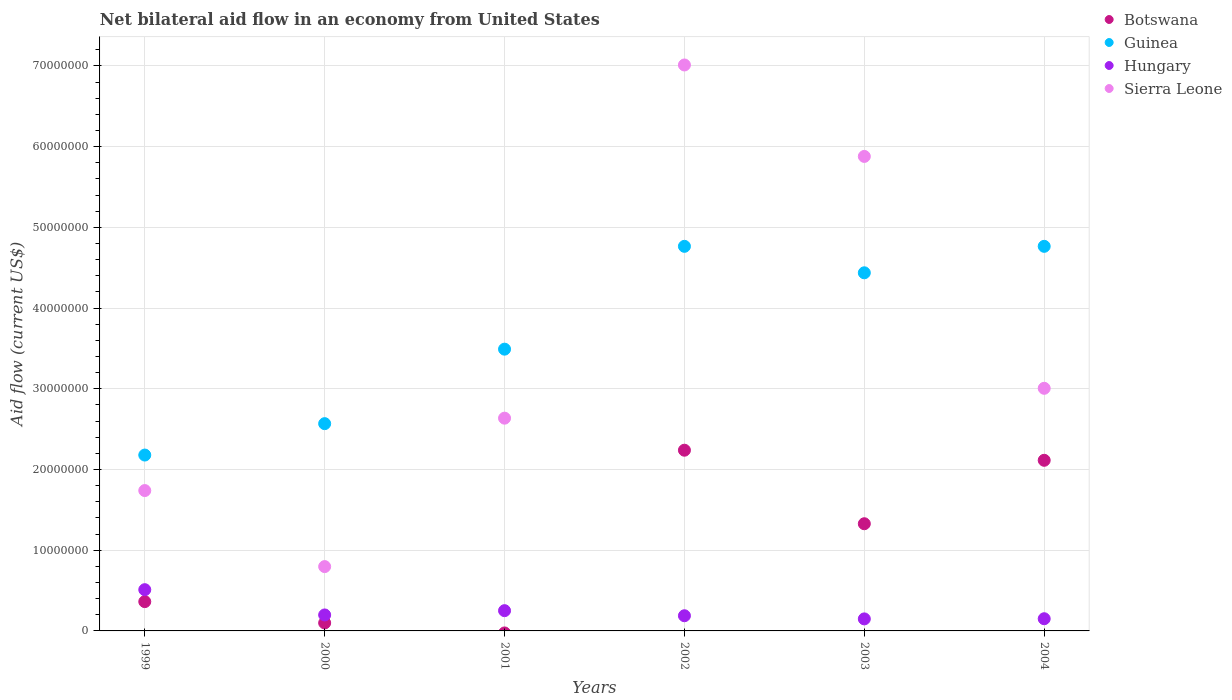How many different coloured dotlines are there?
Keep it short and to the point. 4. Is the number of dotlines equal to the number of legend labels?
Offer a very short reply. No. What is the net bilateral aid flow in Hungary in 2002?
Your answer should be very brief. 1.88e+06. Across all years, what is the maximum net bilateral aid flow in Botswana?
Offer a terse response. 2.24e+07. Across all years, what is the minimum net bilateral aid flow in Guinea?
Your answer should be compact. 2.18e+07. In which year was the net bilateral aid flow in Botswana maximum?
Provide a succinct answer. 2002. What is the total net bilateral aid flow in Hungary in the graph?
Offer a very short reply. 1.45e+07. What is the difference between the net bilateral aid flow in Botswana in 1999 and that in 2002?
Offer a very short reply. -1.88e+07. What is the difference between the net bilateral aid flow in Hungary in 2002 and the net bilateral aid flow in Guinea in 1999?
Your answer should be compact. -1.99e+07. What is the average net bilateral aid flow in Hungary per year?
Give a very brief answer. 2.41e+06. In the year 1999, what is the difference between the net bilateral aid flow in Guinea and net bilateral aid flow in Botswana?
Give a very brief answer. 1.82e+07. What is the ratio of the net bilateral aid flow in Hungary in 2000 to that in 2004?
Your response must be concise. 1.31. Is the difference between the net bilateral aid flow in Guinea in 1999 and 2002 greater than the difference between the net bilateral aid flow in Botswana in 1999 and 2002?
Make the answer very short. No. What is the difference between the highest and the second highest net bilateral aid flow in Guinea?
Give a very brief answer. 0. What is the difference between the highest and the lowest net bilateral aid flow in Guinea?
Give a very brief answer. 2.59e+07. In how many years, is the net bilateral aid flow in Hungary greater than the average net bilateral aid flow in Hungary taken over all years?
Offer a terse response. 2. How many dotlines are there?
Keep it short and to the point. 4. What is the difference between two consecutive major ticks on the Y-axis?
Provide a succinct answer. 1.00e+07. Are the values on the major ticks of Y-axis written in scientific E-notation?
Ensure brevity in your answer.  No. Does the graph contain grids?
Make the answer very short. Yes. Where does the legend appear in the graph?
Offer a very short reply. Top right. How many legend labels are there?
Provide a succinct answer. 4. How are the legend labels stacked?
Offer a terse response. Vertical. What is the title of the graph?
Ensure brevity in your answer.  Net bilateral aid flow in an economy from United States. What is the label or title of the X-axis?
Provide a short and direct response. Years. What is the label or title of the Y-axis?
Offer a very short reply. Aid flow (current US$). What is the Aid flow (current US$) of Botswana in 1999?
Provide a succinct answer. 3.63e+06. What is the Aid flow (current US$) of Guinea in 1999?
Your answer should be very brief. 2.18e+07. What is the Aid flow (current US$) in Hungary in 1999?
Make the answer very short. 5.11e+06. What is the Aid flow (current US$) in Sierra Leone in 1999?
Provide a short and direct response. 1.74e+07. What is the Aid flow (current US$) in Botswana in 2000?
Your response must be concise. 9.90e+05. What is the Aid flow (current US$) of Guinea in 2000?
Give a very brief answer. 2.57e+07. What is the Aid flow (current US$) of Hungary in 2000?
Your response must be concise. 1.98e+06. What is the Aid flow (current US$) of Sierra Leone in 2000?
Offer a terse response. 7.97e+06. What is the Aid flow (current US$) in Botswana in 2001?
Keep it short and to the point. 0. What is the Aid flow (current US$) in Guinea in 2001?
Provide a succinct answer. 3.49e+07. What is the Aid flow (current US$) in Hungary in 2001?
Offer a very short reply. 2.51e+06. What is the Aid flow (current US$) in Sierra Leone in 2001?
Provide a short and direct response. 2.64e+07. What is the Aid flow (current US$) in Botswana in 2002?
Provide a short and direct response. 2.24e+07. What is the Aid flow (current US$) in Guinea in 2002?
Your answer should be compact. 4.76e+07. What is the Aid flow (current US$) of Hungary in 2002?
Your response must be concise. 1.88e+06. What is the Aid flow (current US$) of Sierra Leone in 2002?
Give a very brief answer. 7.01e+07. What is the Aid flow (current US$) of Botswana in 2003?
Your response must be concise. 1.33e+07. What is the Aid flow (current US$) of Guinea in 2003?
Ensure brevity in your answer.  4.44e+07. What is the Aid flow (current US$) of Hungary in 2003?
Give a very brief answer. 1.49e+06. What is the Aid flow (current US$) of Sierra Leone in 2003?
Provide a short and direct response. 5.88e+07. What is the Aid flow (current US$) of Botswana in 2004?
Provide a short and direct response. 2.11e+07. What is the Aid flow (current US$) of Guinea in 2004?
Provide a succinct answer. 4.76e+07. What is the Aid flow (current US$) in Hungary in 2004?
Offer a terse response. 1.51e+06. What is the Aid flow (current US$) in Sierra Leone in 2004?
Your answer should be compact. 3.01e+07. Across all years, what is the maximum Aid flow (current US$) in Botswana?
Provide a succinct answer. 2.24e+07. Across all years, what is the maximum Aid flow (current US$) of Guinea?
Your response must be concise. 4.76e+07. Across all years, what is the maximum Aid flow (current US$) in Hungary?
Keep it short and to the point. 5.11e+06. Across all years, what is the maximum Aid flow (current US$) of Sierra Leone?
Give a very brief answer. 7.01e+07. Across all years, what is the minimum Aid flow (current US$) of Botswana?
Provide a short and direct response. 0. Across all years, what is the minimum Aid flow (current US$) in Guinea?
Make the answer very short. 2.18e+07. Across all years, what is the minimum Aid flow (current US$) of Hungary?
Keep it short and to the point. 1.49e+06. Across all years, what is the minimum Aid flow (current US$) in Sierra Leone?
Your answer should be very brief. 7.97e+06. What is the total Aid flow (current US$) in Botswana in the graph?
Offer a terse response. 6.14e+07. What is the total Aid flow (current US$) of Guinea in the graph?
Make the answer very short. 2.22e+08. What is the total Aid flow (current US$) in Hungary in the graph?
Ensure brevity in your answer.  1.45e+07. What is the total Aid flow (current US$) in Sierra Leone in the graph?
Offer a very short reply. 2.11e+08. What is the difference between the Aid flow (current US$) in Botswana in 1999 and that in 2000?
Provide a short and direct response. 2.64e+06. What is the difference between the Aid flow (current US$) in Guinea in 1999 and that in 2000?
Your answer should be very brief. -3.89e+06. What is the difference between the Aid flow (current US$) in Hungary in 1999 and that in 2000?
Your answer should be compact. 3.13e+06. What is the difference between the Aid flow (current US$) of Sierra Leone in 1999 and that in 2000?
Give a very brief answer. 9.42e+06. What is the difference between the Aid flow (current US$) of Guinea in 1999 and that in 2001?
Your answer should be compact. -1.31e+07. What is the difference between the Aid flow (current US$) of Hungary in 1999 and that in 2001?
Ensure brevity in your answer.  2.60e+06. What is the difference between the Aid flow (current US$) in Sierra Leone in 1999 and that in 2001?
Your response must be concise. -8.97e+06. What is the difference between the Aid flow (current US$) of Botswana in 1999 and that in 2002?
Make the answer very short. -1.88e+07. What is the difference between the Aid flow (current US$) of Guinea in 1999 and that in 2002?
Keep it short and to the point. -2.59e+07. What is the difference between the Aid flow (current US$) in Hungary in 1999 and that in 2002?
Your answer should be compact. 3.23e+06. What is the difference between the Aid flow (current US$) in Sierra Leone in 1999 and that in 2002?
Provide a short and direct response. -5.27e+07. What is the difference between the Aid flow (current US$) of Botswana in 1999 and that in 2003?
Provide a succinct answer. -9.65e+06. What is the difference between the Aid flow (current US$) of Guinea in 1999 and that in 2003?
Make the answer very short. -2.26e+07. What is the difference between the Aid flow (current US$) of Hungary in 1999 and that in 2003?
Your answer should be compact. 3.62e+06. What is the difference between the Aid flow (current US$) of Sierra Leone in 1999 and that in 2003?
Your answer should be compact. -4.14e+07. What is the difference between the Aid flow (current US$) of Botswana in 1999 and that in 2004?
Your answer should be compact. -1.75e+07. What is the difference between the Aid flow (current US$) in Guinea in 1999 and that in 2004?
Offer a very short reply. -2.59e+07. What is the difference between the Aid flow (current US$) of Hungary in 1999 and that in 2004?
Give a very brief answer. 3.60e+06. What is the difference between the Aid flow (current US$) in Sierra Leone in 1999 and that in 2004?
Your response must be concise. -1.27e+07. What is the difference between the Aid flow (current US$) in Guinea in 2000 and that in 2001?
Provide a succinct answer. -9.23e+06. What is the difference between the Aid flow (current US$) in Hungary in 2000 and that in 2001?
Your answer should be compact. -5.30e+05. What is the difference between the Aid flow (current US$) of Sierra Leone in 2000 and that in 2001?
Ensure brevity in your answer.  -1.84e+07. What is the difference between the Aid flow (current US$) of Botswana in 2000 and that in 2002?
Your answer should be compact. -2.14e+07. What is the difference between the Aid flow (current US$) of Guinea in 2000 and that in 2002?
Offer a very short reply. -2.20e+07. What is the difference between the Aid flow (current US$) in Hungary in 2000 and that in 2002?
Give a very brief answer. 1.00e+05. What is the difference between the Aid flow (current US$) of Sierra Leone in 2000 and that in 2002?
Your answer should be very brief. -6.22e+07. What is the difference between the Aid flow (current US$) of Botswana in 2000 and that in 2003?
Give a very brief answer. -1.23e+07. What is the difference between the Aid flow (current US$) in Guinea in 2000 and that in 2003?
Keep it short and to the point. -1.87e+07. What is the difference between the Aid flow (current US$) in Hungary in 2000 and that in 2003?
Offer a very short reply. 4.90e+05. What is the difference between the Aid flow (current US$) in Sierra Leone in 2000 and that in 2003?
Provide a succinct answer. -5.08e+07. What is the difference between the Aid flow (current US$) in Botswana in 2000 and that in 2004?
Keep it short and to the point. -2.02e+07. What is the difference between the Aid flow (current US$) in Guinea in 2000 and that in 2004?
Keep it short and to the point. -2.20e+07. What is the difference between the Aid flow (current US$) in Sierra Leone in 2000 and that in 2004?
Give a very brief answer. -2.21e+07. What is the difference between the Aid flow (current US$) of Guinea in 2001 and that in 2002?
Keep it short and to the point. -1.27e+07. What is the difference between the Aid flow (current US$) of Hungary in 2001 and that in 2002?
Make the answer very short. 6.30e+05. What is the difference between the Aid flow (current US$) in Sierra Leone in 2001 and that in 2002?
Offer a very short reply. -4.38e+07. What is the difference between the Aid flow (current US$) of Guinea in 2001 and that in 2003?
Provide a short and direct response. -9.46e+06. What is the difference between the Aid flow (current US$) in Hungary in 2001 and that in 2003?
Keep it short and to the point. 1.02e+06. What is the difference between the Aid flow (current US$) of Sierra Leone in 2001 and that in 2003?
Offer a very short reply. -3.24e+07. What is the difference between the Aid flow (current US$) in Guinea in 2001 and that in 2004?
Offer a very short reply. -1.27e+07. What is the difference between the Aid flow (current US$) of Sierra Leone in 2001 and that in 2004?
Provide a succinct answer. -3.70e+06. What is the difference between the Aid flow (current US$) in Botswana in 2002 and that in 2003?
Keep it short and to the point. 9.11e+06. What is the difference between the Aid flow (current US$) in Guinea in 2002 and that in 2003?
Keep it short and to the point. 3.28e+06. What is the difference between the Aid flow (current US$) in Hungary in 2002 and that in 2003?
Your answer should be compact. 3.90e+05. What is the difference between the Aid flow (current US$) in Sierra Leone in 2002 and that in 2003?
Your answer should be compact. 1.13e+07. What is the difference between the Aid flow (current US$) in Botswana in 2002 and that in 2004?
Offer a terse response. 1.25e+06. What is the difference between the Aid flow (current US$) of Sierra Leone in 2002 and that in 2004?
Your answer should be very brief. 4.01e+07. What is the difference between the Aid flow (current US$) in Botswana in 2003 and that in 2004?
Ensure brevity in your answer.  -7.86e+06. What is the difference between the Aid flow (current US$) in Guinea in 2003 and that in 2004?
Provide a succinct answer. -3.28e+06. What is the difference between the Aid flow (current US$) in Hungary in 2003 and that in 2004?
Make the answer very short. -2.00e+04. What is the difference between the Aid flow (current US$) in Sierra Leone in 2003 and that in 2004?
Make the answer very short. 2.87e+07. What is the difference between the Aid flow (current US$) in Botswana in 1999 and the Aid flow (current US$) in Guinea in 2000?
Provide a succinct answer. -2.20e+07. What is the difference between the Aid flow (current US$) of Botswana in 1999 and the Aid flow (current US$) of Hungary in 2000?
Provide a short and direct response. 1.65e+06. What is the difference between the Aid flow (current US$) in Botswana in 1999 and the Aid flow (current US$) in Sierra Leone in 2000?
Keep it short and to the point. -4.34e+06. What is the difference between the Aid flow (current US$) in Guinea in 1999 and the Aid flow (current US$) in Hungary in 2000?
Provide a succinct answer. 1.98e+07. What is the difference between the Aid flow (current US$) in Guinea in 1999 and the Aid flow (current US$) in Sierra Leone in 2000?
Offer a very short reply. 1.38e+07. What is the difference between the Aid flow (current US$) of Hungary in 1999 and the Aid flow (current US$) of Sierra Leone in 2000?
Your response must be concise. -2.86e+06. What is the difference between the Aid flow (current US$) in Botswana in 1999 and the Aid flow (current US$) in Guinea in 2001?
Ensure brevity in your answer.  -3.13e+07. What is the difference between the Aid flow (current US$) in Botswana in 1999 and the Aid flow (current US$) in Hungary in 2001?
Provide a short and direct response. 1.12e+06. What is the difference between the Aid flow (current US$) of Botswana in 1999 and the Aid flow (current US$) of Sierra Leone in 2001?
Offer a terse response. -2.27e+07. What is the difference between the Aid flow (current US$) of Guinea in 1999 and the Aid flow (current US$) of Hungary in 2001?
Offer a terse response. 1.93e+07. What is the difference between the Aid flow (current US$) in Guinea in 1999 and the Aid flow (current US$) in Sierra Leone in 2001?
Keep it short and to the point. -4.57e+06. What is the difference between the Aid flow (current US$) of Hungary in 1999 and the Aid flow (current US$) of Sierra Leone in 2001?
Make the answer very short. -2.12e+07. What is the difference between the Aid flow (current US$) of Botswana in 1999 and the Aid flow (current US$) of Guinea in 2002?
Offer a very short reply. -4.40e+07. What is the difference between the Aid flow (current US$) of Botswana in 1999 and the Aid flow (current US$) of Hungary in 2002?
Provide a succinct answer. 1.75e+06. What is the difference between the Aid flow (current US$) of Botswana in 1999 and the Aid flow (current US$) of Sierra Leone in 2002?
Provide a short and direct response. -6.65e+07. What is the difference between the Aid flow (current US$) of Guinea in 1999 and the Aid flow (current US$) of Hungary in 2002?
Provide a short and direct response. 1.99e+07. What is the difference between the Aid flow (current US$) in Guinea in 1999 and the Aid flow (current US$) in Sierra Leone in 2002?
Provide a short and direct response. -4.83e+07. What is the difference between the Aid flow (current US$) of Hungary in 1999 and the Aid flow (current US$) of Sierra Leone in 2002?
Keep it short and to the point. -6.50e+07. What is the difference between the Aid flow (current US$) of Botswana in 1999 and the Aid flow (current US$) of Guinea in 2003?
Your answer should be very brief. -4.07e+07. What is the difference between the Aid flow (current US$) of Botswana in 1999 and the Aid flow (current US$) of Hungary in 2003?
Your answer should be very brief. 2.14e+06. What is the difference between the Aid flow (current US$) in Botswana in 1999 and the Aid flow (current US$) in Sierra Leone in 2003?
Your response must be concise. -5.52e+07. What is the difference between the Aid flow (current US$) of Guinea in 1999 and the Aid flow (current US$) of Hungary in 2003?
Make the answer very short. 2.03e+07. What is the difference between the Aid flow (current US$) of Guinea in 1999 and the Aid flow (current US$) of Sierra Leone in 2003?
Keep it short and to the point. -3.70e+07. What is the difference between the Aid flow (current US$) in Hungary in 1999 and the Aid flow (current US$) in Sierra Leone in 2003?
Offer a terse response. -5.37e+07. What is the difference between the Aid flow (current US$) in Botswana in 1999 and the Aid flow (current US$) in Guinea in 2004?
Provide a short and direct response. -4.40e+07. What is the difference between the Aid flow (current US$) in Botswana in 1999 and the Aid flow (current US$) in Hungary in 2004?
Make the answer very short. 2.12e+06. What is the difference between the Aid flow (current US$) in Botswana in 1999 and the Aid flow (current US$) in Sierra Leone in 2004?
Make the answer very short. -2.64e+07. What is the difference between the Aid flow (current US$) in Guinea in 1999 and the Aid flow (current US$) in Hungary in 2004?
Keep it short and to the point. 2.03e+07. What is the difference between the Aid flow (current US$) in Guinea in 1999 and the Aid flow (current US$) in Sierra Leone in 2004?
Your response must be concise. -8.27e+06. What is the difference between the Aid flow (current US$) of Hungary in 1999 and the Aid flow (current US$) of Sierra Leone in 2004?
Your answer should be very brief. -2.50e+07. What is the difference between the Aid flow (current US$) of Botswana in 2000 and the Aid flow (current US$) of Guinea in 2001?
Your answer should be compact. -3.39e+07. What is the difference between the Aid flow (current US$) in Botswana in 2000 and the Aid flow (current US$) in Hungary in 2001?
Ensure brevity in your answer.  -1.52e+06. What is the difference between the Aid flow (current US$) of Botswana in 2000 and the Aid flow (current US$) of Sierra Leone in 2001?
Keep it short and to the point. -2.54e+07. What is the difference between the Aid flow (current US$) of Guinea in 2000 and the Aid flow (current US$) of Hungary in 2001?
Offer a terse response. 2.32e+07. What is the difference between the Aid flow (current US$) in Guinea in 2000 and the Aid flow (current US$) in Sierra Leone in 2001?
Your answer should be compact. -6.80e+05. What is the difference between the Aid flow (current US$) of Hungary in 2000 and the Aid flow (current US$) of Sierra Leone in 2001?
Give a very brief answer. -2.44e+07. What is the difference between the Aid flow (current US$) of Botswana in 2000 and the Aid flow (current US$) of Guinea in 2002?
Offer a terse response. -4.67e+07. What is the difference between the Aid flow (current US$) in Botswana in 2000 and the Aid flow (current US$) in Hungary in 2002?
Your answer should be compact. -8.90e+05. What is the difference between the Aid flow (current US$) in Botswana in 2000 and the Aid flow (current US$) in Sierra Leone in 2002?
Provide a succinct answer. -6.91e+07. What is the difference between the Aid flow (current US$) in Guinea in 2000 and the Aid flow (current US$) in Hungary in 2002?
Offer a terse response. 2.38e+07. What is the difference between the Aid flow (current US$) in Guinea in 2000 and the Aid flow (current US$) in Sierra Leone in 2002?
Keep it short and to the point. -4.44e+07. What is the difference between the Aid flow (current US$) of Hungary in 2000 and the Aid flow (current US$) of Sierra Leone in 2002?
Keep it short and to the point. -6.81e+07. What is the difference between the Aid flow (current US$) of Botswana in 2000 and the Aid flow (current US$) of Guinea in 2003?
Your answer should be compact. -4.34e+07. What is the difference between the Aid flow (current US$) of Botswana in 2000 and the Aid flow (current US$) of Hungary in 2003?
Offer a terse response. -5.00e+05. What is the difference between the Aid flow (current US$) of Botswana in 2000 and the Aid flow (current US$) of Sierra Leone in 2003?
Ensure brevity in your answer.  -5.78e+07. What is the difference between the Aid flow (current US$) of Guinea in 2000 and the Aid flow (current US$) of Hungary in 2003?
Offer a terse response. 2.42e+07. What is the difference between the Aid flow (current US$) in Guinea in 2000 and the Aid flow (current US$) in Sierra Leone in 2003?
Give a very brief answer. -3.31e+07. What is the difference between the Aid flow (current US$) of Hungary in 2000 and the Aid flow (current US$) of Sierra Leone in 2003?
Make the answer very short. -5.68e+07. What is the difference between the Aid flow (current US$) in Botswana in 2000 and the Aid flow (current US$) in Guinea in 2004?
Your answer should be compact. -4.67e+07. What is the difference between the Aid flow (current US$) in Botswana in 2000 and the Aid flow (current US$) in Hungary in 2004?
Make the answer very short. -5.20e+05. What is the difference between the Aid flow (current US$) of Botswana in 2000 and the Aid flow (current US$) of Sierra Leone in 2004?
Ensure brevity in your answer.  -2.91e+07. What is the difference between the Aid flow (current US$) of Guinea in 2000 and the Aid flow (current US$) of Hungary in 2004?
Your response must be concise. 2.42e+07. What is the difference between the Aid flow (current US$) of Guinea in 2000 and the Aid flow (current US$) of Sierra Leone in 2004?
Your response must be concise. -4.38e+06. What is the difference between the Aid flow (current US$) in Hungary in 2000 and the Aid flow (current US$) in Sierra Leone in 2004?
Make the answer very short. -2.81e+07. What is the difference between the Aid flow (current US$) of Guinea in 2001 and the Aid flow (current US$) of Hungary in 2002?
Provide a short and direct response. 3.30e+07. What is the difference between the Aid flow (current US$) of Guinea in 2001 and the Aid flow (current US$) of Sierra Leone in 2002?
Provide a short and direct response. -3.52e+07. What is the difference between the Aid flow (current US$) in Hungary in 2001 and the Aid flow (current US$) in Sierra Leone in 2002?
Offer a very short reply. -6.76e+07. What is the difference between the Aid flow (current US$) in Guinea in 2001 and the Aid flow (current US$) in Hungary in 2003?
Offer a very short reply. 3.34e+07. What is the difference between the Aid flow (current US$) of Guinea in 2001 and the Aid flow (current US$) of Sierra Leone in 2003?
Offer a terse response. -2.39e+07. What is the difference between the Aid flow (current US$) of Hungary in 2001 and the Aid flow (current US$) of Sierra Leone in 2003?
Offer a very short reply. -5.63e+07. What is the difference between the Aid flow (current US$) in Guinea in 2001 and the Aid flow (current US$) in Hungary in 2004?
Provide a short and direct response. 3.34e+07. What is the difference between the Aid flow (current US$) of Guinea in 2001 and the Aid flow (current US$) of Sierra Leone in 2004?
Offer a very short reply. 4.85e+06. What is the difference between the Aid flow (current US$) in Hungary in 2001 and the Aid flow (current US$) in Sierra Leone in 2004?
Make the answer very short. -2.76e+07. What is the difference between the Aid flow (current US$) of Botswana in 2002 and the Aid flow (current US$) of Guinea in 2003?
Give a very brief answer. -2.20e+07. What is the difference between the Aid flow (current US$) in Botswana in 2002 and the Aid flow (current US$) in Hungary in 2003?
Provide a succinct answer. 2.09e+07. What is the difference between the Aid flow (current US$) of Botswana in 2002 and the Aid flow (current US$) of Sierra Leone in 2003?
Offer a very short reply. -3.64e+07. What is the difference between the Aid flow (current US$) of Guinea in 2002 and the Aid flow (current US$) of Hungary in 2003?
Ensure brevity in your answer.  4.62e+07. What is the difference between the Aid flow (current US$) of Guinea in 2002 and the Aid flow (current US$) of Sierra Leone in 2003?
Ensure brevity in your answer.  -1.11e+07. What is the difference between the Aid flow (current US$) in Hungary in 2002 and the Aid flow (current US$) in Sierra Leone in 2003?
Your answer should be compact. -5.69e+07. What is the difference between the Aid flow (current US$) of Botswana in 2002 and the Aid flow (current US$) of Guinea in 2004?
Provide a short and direct response. -2.53e+07. What is the difference between the Aid flow (current US$) of Botswana in 2002 and the Aid flow (current US$) of Hungary in 2004?
Make the answer very short. 2.09e+07. What is the difference between the Aid flow (current US$) in Botswana in 2002 and the Aid flow (current US$) in Sierra Leone in 2004?
Provide a succinct answer. -7.67e+06. What is the difference between the Aid flow (current US$) in Guinea in 2002 and the Aid flow (current US$) in Hungary in 2004?
Give a very brief answer. 4.61e+07. What is the difference between the Aid flow (current US$) in Guinea in 2002 and the Aid flow (current US$) in Sierra Leone in 2004?
Provide a succinct answer. 1.76e+07. What is the difference between the Aid flow (current US$) in Hungary in 2002 and the Aid flow (current US$) in Sierra Leone in 2004?
Give a very brief answer. -2.82e+07. What is the difference between the Aid flow (current US$) in Botswana in 2003 and the Aid flow (current US$) in Guinea in 2004?
Provide a succinct answer. -3.44e+07. What is the difference between the Aid flow (current US$) of Botswana in 2003 and the Aid flow (current US$) of Hungary in 2004?
Offer a terse response. 1.18e+07. What is the difference between the Aid flow (current US$) in Botswana in 2003 and the Aid flow (current US$) in Sierra Leone in 2004?
Ensure brevity in your answer.  -1.68e+07. What is the difference between the Aid flow (current US$) in Guinea in 2003 and the Aid flow (current US$) in Hungary in 2004?
Your answer should be compact. 4.29e+07. What is the difference between the Aid flow (current US$) of Guinea in 2003 and the Aid flow (current US$) of Sierra Leone in 2004?
Keep it short and to the point. 1.43e+07. What is the difference between the Aid flow (current US$) in Hungary in 2003 and the Aid flow (current US$) in Sierra Leone in 2004?
Offer a very short reply. -2.86e+07. What is the average Aid flow (current US$) in Botswana per year?
Offer a terse response. 1.02e+07. What is the average Aid flow (current US$) of Guinea per year?
Keep it short and to the point. 3.70e+07. What is the average Aid flow (current US$) of Hungary per year?
Provide a short and direct response. 2.41e+06. What is the average Aid flow (current US$) of Sierra Leone per year?
Give a very brief answer. 3.51e+07. In the year 1999, what is the difference between the Aid flow (current US$) in Botswana and Aid flow (current US$) in Guinea?
Provide a succinct answer. -1.82e+07. In the year 1999, what is the difference between the Aid flow (current US$) of Botswana and Aid flow (current US$) of Hungary?
Your answer should be very brief. -1.48e+06. In the year 1999, what is the difference between the Aid flow (current US$) in Botswana and Aid flow (current US$) in Sierra Leone?
Provide a short and direct response. -1.38e+07. In the year 1999, what is the difference between the Aid flow (current US$) of Guinea and Aid flow (current US$) of Hungary?
Keep it short and to the point. 1.67e+07. In the year 1999, what is the difference between the Aid flow (current US$) of Guinea and Aid flow (current US$) of Sierra Leone?
Provide a short and direct response. 4.40e+06. In the year 1999, what is the difference between the Aid flow (current US$) of Hungary and Aid flow (current US$) of Sierra Leone?
Provide a succinct answer. -1.23e+07. In the year 2000, what is the difference between the Aid flow (current US$) of Botswana and Aid flow (current US$) of Guinea?
Offer a terse response. -2.47e+07. In the year 2000, what is the difference between the Aid flow (current US$) of Botswana and Aid flow (current US$) of Hungary?
Offer a terse response. -9.90e+05. In the year 2000, what is the difference between the Aid flow (current US$) in Botswana and Aid flow (current US$) in Sierra Leone?
Make the answer very short. -6.98e+06. In the year 2000, what is the difference between the Aid flow (current US$) of Guinea and Aid flow (current US$) of Hungary?
Offer a very short reply. 2.37e+07. In the year 2000, what is the difference between the Aid flow (current US$) in Guinea and Aid flow (current US$) in Sierra Leone?
Provide a succinct answer. 1.77e+07. In the year 2000, what is the difference between the Aid flow (current US$) of Hungary and Aid flow (current US$) of Sierra Leone?
Make the answer very short. -5.99e+06. In the year 2001, what is the difference between the Aid flow (current US$) in Guinea and Aid flow (current US$) in Hungary?
Offer a very short reply. 3.24e+07. In the year 2001, what is the difference between the Aid flow (current US$) of Guinea and Aid flow (current US$) of Sierra Leone?
Provide a succinct answer. 8.55e+06. In the year 2001, what is the difference between the Aid flow (current US$) of Hungary and Aid flow (current US$) of Sierra Leone?
Provide a succinct answer. -2.38e+07. In the year 2002, what is the difference between the Aid flow (current US$) in Botswana and Aid flow (current US$) in Guinea?
Make the answer very short. -2.53e+07. In the year 2002, what is the difference between the Aid flow (current US$) of Botswana and Aid flow (current US$) of Hungary?
Your response must be concise. 2.05e+07. In the year 2002, what is the difference between the Aid flow (current US$) in Botswana and Aid flow (current US$) in Sierra Leone?
Make the answer very short. -4.77e+07. In the year 2002, what is the difference between the Aid flow (current US$) in Guinea and Aid flow (current US$) in Hungary?
Ensure brevity in your answer.  4.58e+07. In the year 2002, what is the difference between the Aid flow (current US$) in Guinea and Aid flow (current US$) in Sierra Leone?
Your answer should be very brief. -2.25e+07. In the year 2002, what is the difference between the Aid flow (current US$) of Hungary and Aid flow (current US$) of Sierra Leone?
Provide a short and direct response. -6.82e+07. In the year 2003, what is the difference between the Aid flow (current US$) in Botswana and Aid flow (current US$) in Guinea?
Your response must be concise. -3.11e+07. In the year 2003, what is the difference between the Aid flow (current US$) in Botswana and Aid flow (current US$) in Hungary?
Make the answer very short. 1.18e+07. In the year 2003, what is the difference between the Aid flow (current US$) of Botswana and Aid flow (current US$) of Sierra Leone?
Offer a very short reply. -4.55e+07. In the year 2003, what is the difference between the Aid flow (current US$) of Guinea and Aid flow (current US$) of Hungary?
Provide a short and direct response. 4.29e+07. In the year 2003, what is the difference between the Aid flow (current US$) of Guinea and Aid flow (current US$) of Sierra Leone?
Give a very brief answer. -1.44e+07. In the year 2003, what is the difference between the Aid flow (current US$) of Hungary and Aid flow (current US$) of Sierra Leone?
Keep it short and to the point. -5.73e+07. In the year 2004, what is the difference between the Aid flow (current US$) in Botswana and Aid flow (current US$) in Guinea?
Ensure brevity in your answer.  -2.65e+07. In the year 2004, what is the difference between the Aid flow (current US$) of Botswana and Aid flow (current US$) of Hungary?
Your answer should be very brief. 1.96e+07. In the year 2004, what is the difference between the Aid flow (current US$) in Botswana and Aid flow (current US$) in Sierra Leone?
Give a very brief answer. -8.92e+06. In the year 2004, what is the difference between the Aid flow (current US$) in Guinea and Aid flow (current US$) in Hungary?
Provide a short and direct response. 4.61e+07. In the year 2004, what is the difference between the Aid flow (current US$) of Guinea and Aid flow (current US$) of Sierra Leone?
Your answer should be compact. 1.76e+07. In the year 2004, what is the difference between the Aid flow (current US$) of Hungary and Aid flow (current US$) of Sierra Leone?
Provide a succinct answer. -2.86e+07. What is the ratio of the Aid flow (current US$) in Botswana in 1999 to that in 2000?
Your answer should be compact. 3.67. What is the ratio of the Aid flow (current US$) in Guinea in 1999 to that in 2000?
Provide a short and direct response. 0.85. What is the ratio of the Aid flow (current US$) of Hungary in 1999 to that in 2000?
Make the answer very short. 2.58. What is the ratio of the Aid flow (current US$) of Sierra Leone in 1999 to that in 2000?
Ensure brevity in your answer.  2.18. What is the ratio of the Aid flow (current US$) in Guinea in 1999 to that in 2001?
Make the answer very short. 0.62. What is the ratio of the Aid flow (current US$) of Hungary in 1999 to that in 2001?
Provide a short and direct response. 2.04. What is the ratio of the Aid flow (current US$) in Sierra Leone in 1999 to that in 2001?
Make the answer very short. 0.66. What is the ratio of the Aid flow (current US$) in Botswana in 1999 to that in 2002?
Your answer should be very brief. 0.16. What is the ratio of the Aid flow (current US$) in Guinea in 1999 to that in 2002?
Offer a very short reply. 0.46. What is the ratio of the Aid flow (current US$) in Hungary in 1999 to that in 2002?
Provide a short and direct response. 2.72. What is the ratio of the Aid flow (current US$) of Sierra Leone in 1999 to that in 2002?
Provide a short and direct response. 0.25. What is the ratio of the Aid flow (current US$) in Botswana in 1999 to that in 2003?
Your answer should be very brief. 0.27. What is the ratio of the Aid flow (current US$) of Guinea in 1999 to that in 2003?
Your response must be concise. 0.49. What is the ratio of the Aid flow (current US$) in Hungary in 1999 to that in 2003?
Provide a short and direct response. 3.43. What is the ratio of the Aid flow (current US$) of Sierra Leone in 1999 to that in 2003?
Keep it short and to the point. 0.3. What is the ratio of the Aid flow (current US$) in Botswana in 1999 to that in 2004?
Make the answer very short. 0.17. What is the ratio of the Aid flow (current US$) in Guinea in 1999 to that in 2004?
Provide a succinct answer. 0.46. What is the ratio of the Aid flow (current US$) in Hungary in 1999 to that in 2004?
Offer a terse response. 3.38. What is the ratio of the Aid flow (current US$) in Sierra Leone in 1999 to that in 2004?
Your answer should be very brief. 0.58. What is the ratio of the Aid flow (current US$) of Guinea in 2000 to that in 2001?
Keep it short and to the point. 0.74. What is the ratio of the Aid flow (current US$) in Hungary in 2000 to that in 2001?
Offer a terse response. 0.79. What is the ratio of the Aid flow (current US$) of Sierra Leone in 2000 to that in 2001?
Your answer should be compact. 0.3. What is the ratio of the Aid flow (current US$) of Botswana in 2000 to that in 2002?
Keep it short and to the point. 0.04. What is the ratio of the Aid flow (current US$) in Guinea in 2000 to that in 2002?
Offer a very short reply. 0.54. What is the ratio of the Aid flow (current US$) in Hungary in 2000 to that in 2002?
Make the answer very short. 1.05. What is the ratio of the Aid flow (current US$) of Sierra Leone in 2000 to that in 2002?
Offer a terse response. 0.11. What is the ratio of the Aid flow (current US$) in Botswana in 2000 to that in 2003?
Offer a terse response. 0.07. What is the ratio of the Aid flow (current US$) in Guinea in 2000 to that in 2003?
Your answer should be very brief. 0.58. What is the ratio of the Aid flow (current US$) in Hungary in 2000 to that in 2003?
Keep it short and to the point. 1.33. What is the ratio of the Aid flow (current US$) in Sierra Leone in 2000 to that in 2003?
Make the answer very short. 0.14. What is the ratio of the Aid flow (current US$) in Botswana in 2000 to that in 2004?
Provide a short and direct response. 0.05. What is the ratio of the Aid flow (current US$) of Guinea in 2000 to that in 2004?
Offer a terse response. 0.54. What is the ratio of the Aid flow (current US$) of Hungary in 2000 to that in 2004?
Ensure brevity in your answer.  1.31. What is the ratio of the Aid flow (current US$) in Sierra Leone in 2000 to that in 2004?
Ensure brevity in your answer.  0.27. What is the ratio of the Aid flow (current US$) of Guinea in 2001 to that in 2002?
Your answer should be very brief. 0.73. What is the ratio of the Aid flow (current US$) of Hungary in 2001 to that in 2002?
Offer a very short reply. 1.34. What is the ratio of the Aid flow (current US$) in Sierra Leone in 2001 to that in 2002?
Keep it short and to the point. 0.38. What is the ratio of the Aid flow (current US$) in Guinea in 2001 to that in 2003?
Ensure brevity in your answer.  0.79. What is the ratio of the Aid flow (current US$) in Hungary in 2001 to that in 2003?
Make the answer very short. 1.68. What is the ratio of the Aid flow (current US$) of Sierra Leone in 2001 to that in 2003?
Provide a succinct answer. 0.45. What is the ratio of the Aid flow (current US$) in Guinea in 2001 to that in 2004?
Provide a succinct answer. 0.73. What is the ratio of the Aid flow (current US$) of Hungary in 2001 to that in 2004?
Ensure brevity in your answer.  1.66. What is the ratio of the Aid flow (current US$) in Sierra Leone in 2001 to that in 2004?
Give a very brief answer. 0.88. What is the ratio of the Aid flow (current US$) in Botswana in 2002 to that in 2003?
Ensure brevity in your answer.  1.69. What is the ratio of the Aid flow (current US$) of Guinea in 2002 to that in 2003?
Provide a short and direct response. 1.07. What is the ratio of the Aid flow (current US$) in Hungary in 2002 to that in 2003?
Keep it short and to the point. 1.26. What is the ratio of the Aid flow (current US$) of Sierra Leone in 2002 to that in 2003?
Make the answer very short. 1.19. What is the ratio of the Aid flow (current US$) of Botswana in 2002 to that in 2004?
Offer a terse response. 1.06. What is the ratio of the Aid flow (current US$) of Guinea in 2002 to that in 2004?
Make the answer very short. 1. What is the ratio of the Aid flow (current US$) of Hungary in 2002 to that in 2004?
Provide a short and direct response. 1.25. What is the ratio of the Aid flow (current US$) in Sierra Leone in 2002 to that in 2004?
Offer a terse response. 2.33. What is the ratio of the Aid flow (current US$) in Botswana in 2003 to that in 2004?
Your answer should be compact. 0.63. What is the ratio of the Aid flow (current US$) of Guinea in 2003 to that in 2004?
Give a very brief answer. 0.93. What is the ratio of the Aid flow (current US$) in Sierra Leone in 2003 to that in 2004?
Provide a succinct answer. 1.96. What is the difference between the highest and the second highest Aid flow (current US$) of Botswana?
Your answer should be very brief. 1.25e+06. What is the difference between the highest and the second highest Aid flow (current US$) of Guinea?
Your answer should be compact. 0. What is the difference between the highest and the second highest Aid flow (current US$) of Hungary?
Your response must be concise. 2.60e+06. What is the difference between the highest and the second highest Aid flow (current US$) in Sierra Leone?
Your answer should be very brief. 1.13e+07. What is the difference between the highest and the lowest Aid flow (current US$) in Botswana?
Provide a succinct answer. 2.24e+07. What is the difference between the highest and the lowest Aid flow (current US$) of Guinea?
Offer a very short reply. 2.59e+07. What is the difference between the highest and the lowest Aid flow (current US$) in Hungary?
Your response must be concise. 3.62e+06. What is the difference between the highest and the lowest Aid flow (current US$) in Sierra Leone?
Offer a very short reply. 6.22e+07. 